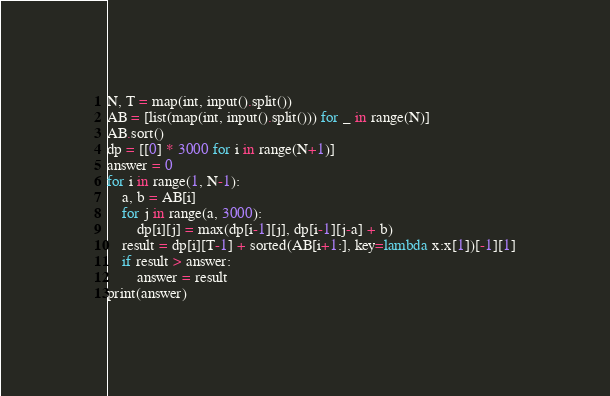Convert code to text. <code><loc_0><loc_0><loc_500><loc_500><_Python_>N, T = map(int, input().split())
AB = [list(map(int, input().split())) for _ in range(N)]
AB.sort()
dp = [[0] * 3000 for i in range(N+1)]
answer = 0
for i in range(1, N-1):
    a, b = AB[i]
    for j in range(a, 3000):
        dp[i][j] = max(dp[i-1][j], dp[i-1][j-a] + b)
    result = dp[i][T-1] + sorted(AB[i+1:], key=lambda x:x[1])[-1][1]
    if result > answer:
        answer = result
print(answer)</code> 